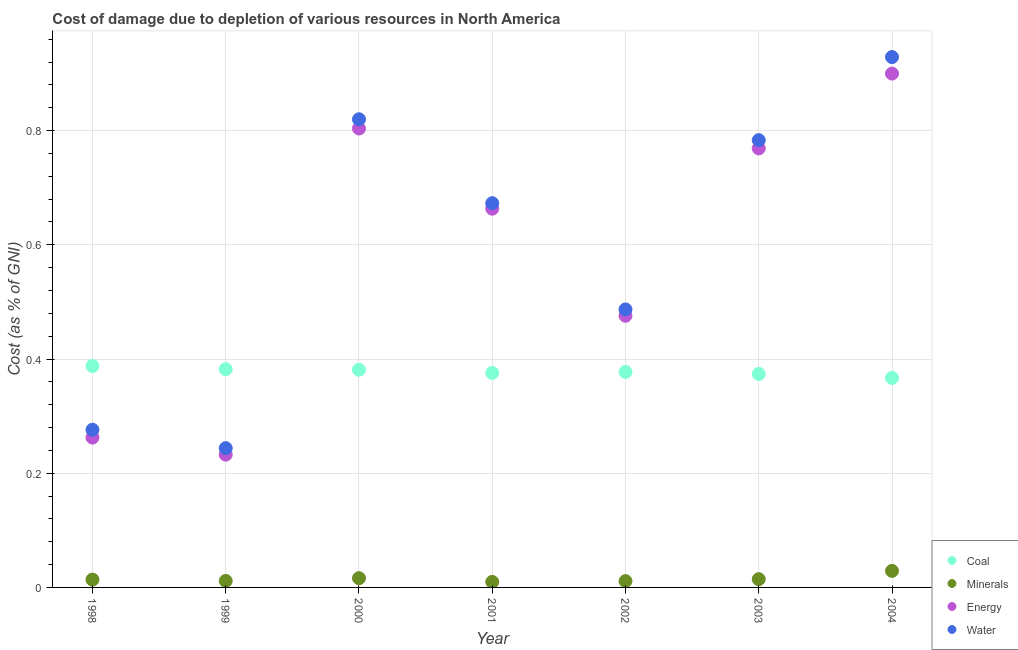How many different coloured dotlines are there?
Offer a very short reply. 4. Is the number of dotlines equal to the number of legend labels?
Your response must be concise. Yes. What is the cost of damage due to depletion of energy in 2001?
Offer a very short reply. 0.66. Across all years, what is the maximum cost of damage due to depletion of water?
Your response must be concise. 0.93. Across all years, what is the minimum cost of damage due to depletion of water?
Your answer should be compact. 0.24. In which year was the cost of damage due to depletion of water minimum?
Make the answer very short. 1999. What is the total cost of damage due to depletion of energy in the graph?
Offer a very short reply. 4.11. What is the difference between the cost of damage due to depletion of energy in 1998 and that in 1999?
Make the answer very short. 0.03. What is the difference between the cost of damage due to depletion of water in 2002 and the cost of damage due to depletion of minerals in 2000?
Make the answer very short. 0.47. What is the average cost of damage due to depletion of minerals per year?
Provide a succinct answer. 0.02. In the year 2000, what is the difference between the cost of damage due to depletion of coal and cost of damage due to depletion of energy?
Ensure brevity in your answer.  -0.42. What is the ratio of the cost of damage due to depletion of minerals in 2003 to that in 2004?
Your response must be concise. 0.5. What is the difference between the highest and the second highest cost of damage due to depletion of coal?
Offer a terse response. 0.01. What is the difference between the highest and the lowest cost of damage due to depletion of coal?
Your response must be concise. 0.02. Is the sum of the cost of damage due to depletion of energy in 2000 and 2001 greater than the maximum cost of damage due to depletion of minerals across all years?
Your answer should be compact. Yes. Is it the case that in every year, the sum of the cost of damage due to depletion of water and cost of damage due to depletion of coal is greater than the sum of cost of damage due to depletion of minerals and cost of damage due to depletion of energy?
Provide a succinct answer. No. Is it the case that in every year, the sum of the cost of damage due to depletion of coal and cost of damage due to depletion of minerals is greater than the cost of damage due to depletion of energy?
Keep it short and to the point. No. Does the cost of damage due to depletion of minerals monotonically increase over the years?
Ensure brevity in your answer.  No. Is the cost of damage due to depletion of minerals strictly greater than the cost of damage due to depletion of water over the years?
Provide a short and direct response. No. Is the cost of damage due to depletion of minerals strictly less than the cost of damage due to depletion of water over the years?
Ensure brevity in your answer.  Yes. How many dotlines are there?
Provide a succinct answer. 4. Does the graph contain grids?
Offer a terse response. Yes. What is the title of the graph?
Provide a short and direct response. Cost of damage due to depletion of various resources in North America . What is the label or title of the X-axis?
Provide a succinct answer. Year. What is the label or title of the Y-axis?
Ensure brevity in your answer.  Cost (as % of GNI). What is the Cost (as % of GNI) of Coal in 1998?
Give a very brief answer. 0.39. What is the Cost (as % of GNI) of Minerals in 1998?
Offer a terse response. 0.01. What is the Cost (as % of GNI) in Energy in 1998?
Provide a short and direct response. 0.26. What is the Cost (as % of GNI) of Water in 1998?
Your answer should be compact. 0.28. What is the Cost (as % of GNI) of Coal in 1999?
Provide a succinct answer. 0.38. What is the Cost (as % of GNI) of Minerals in 1999?
Give a very brief answer. 0.01. What is the Cost (as % of GNI) of Energy in 1999?
Keep it short and to the point. 0.23. What is the Cost (as % of GNI) of Water in 1999?
Ensure brevity in your answer.  0.24. What is the Cost (as % of GNI) of Coal in 2000?
Provide a succinct answer. 0.38. What is the Cost (as % of GNI) in Minerals in 2000?
Your answer should be very brief. 0.02. What is the Cost (as % of GNI) of Energy in 2000?
Your answer should be compact. 0.8. What is the Cost (as % of GNI) of Water in 2000?
Your answer should be very brief. 0.82. What is the Cost (as % of GNI) of Coal in 2001?
Provide a succinct answer. 0.38. What is the Cost (as % of GNI) of Minerals in 2001?
Provide a succinct answer. 0.01. What is the Cost (as % of GNI) of Energy in 2001?
Keep it short and to the point. 0.66. What is the Cost (as % of GNI) in Water in 2001?
Offer a very short reply. 0.67. What is the Cost (as % of GNI) in Coal in 2002?
Make the answer very short. 0.38. What is the Cost (as % of GNI) of Minerals in 2002?
Provide a short and direct response. 0.01. What is the Cost (as % of GNI) in Energy in 2002?
Your answer should be very brief. 0.48. What is the Cost (as % of GNI) in Water in 2002?
Your response must be concise. 0.49. What is the Cost (as % of GNI) in Coal in 2003?
Make the answer very short. 0.37. What is the Cost (as % of GNI) of Minerals in 2003?
Offer a terse response. 0.01. What is the Cost (as % of GNI) in Energy in 2003?
Offer a very short reply. 0.77. What is the Cost (as % of GNI) in Water in 2003?
Your answer should be very brief. 0.78. What is the Cost (as % of GNI) of Coal in 2004?
Give a very brief answer. 0.37. What is the Cost (as % of GNI) of Minerals in 2004?
Give a very brief answer. 0.03. What is the Cost (as % of GNI) in Energy in 2004?
Your response must be concise. 0.9. What is the Cost (as % of GNI) of Water in 2004?
Ensure brevity in your answer.  0.93. Across all years, what is the maximum Cost (as % of GNI) in Coal?
Make the answer very short. 0.39. Across all years, what is the maximum Cost (as % of GNI) in Minerals?
Offer a terse response. 0.03. Across all years, what is the maximum Cost (as % of GNI) in Energy?
Provide a succinct answer. 0.9. Across all years, what is the maximum Cost (as % of GNI) of Water?
Ensure brevity in your answer.  0.93. Across all years, what is the minimum Cost (as % of GNI) in Coal?
Your answer should be compact. 0.37. Across all years, what is the minimum Cost (as % of GNI) of Minerals?
Ensure brevity in your answer.  0.01. Across all years, what is the minimum Cost (as % of GNI) of Energy?
Your answer should be very brief. 0.23. Across all years, what is the minimum Cost (as % of GNI) of Water?
Offer a very short reply. 0.24. What is the total Cost (as % of GNI) in Coal in the graph?
Your answer should be compact. 2.65. What is the total Cost (as % of GNI) in Minerals in the graph?
Provide a succinct answer. 0.11. What is the total Cost (as % of GNI) of Energy in the graph?
Your response must be concise. 4.11. What is the total Cost (as % of GNI) of Water in the graph?
Your response must be concise. 4.21. What is the difference between the Cost (as % of GNI) in Coal in 1998 and that in 1999?
Offer a terse response. 0.01. What is the difference between the Cost (as % of GNI) of Minerals in 1998 and that in 1999?
Make the answer very short. 0. What is the difference between the Cost (as % of GNI) of Energy in 1998 and that in 1999?
Offer a very short reply. 0.03. What is the difference between the Cost (as % of GNI) in Water in 1998 and that in 1999?
Keep it short and to the point. 0.03. What is the difference between the Cost (as % of GNI) in Coal in 1998 and that in 2000?
Your answer should be very brief. 0.01. What is the difference between the Cost (as % of GNI) of Minerals in 1998 and that in 2000?
Your answer should be compact. -0. What is the difference between the Cost (as % of GNI) of Energy in 1998 and that in 2000?
Provide a short and direct response. -0.54. What is the difference between the Cost (as % of GNI) in Water in 1998 and that in 2000?
Your answer should be compact. -0.54. What is the difference between the Cost (as % of GNI) of Coal in 1998 and that in 2001?
Offer a very short reply. 0.01. What is the difference between the Cost (as % of GNI) of Minerals in 1998 and that in 2001?
Give a very brief answer. 0. What is the difference between the Cost (as % of GNI) in Energy in 1998 and that in 2001?
Your response must be concise. -0.4. What is the difference between the Cost (as % of GNI) of Water in 1998 and that in 2001?
Your answer should be very brief. -0.4. What is the difference between the Cost (as % of GNI) of Coal in 1998 and that in 2002?
Provide a short and direct response. 0.01. What is the difference between the Cost (as % of GNI) in Minerals in 1998 and that in 2002?
Provide a short and direct response. 0. What is the difference between the Cost (as % of GNI) in Energy in 1998 and that in 2002?
Offer a very short reply. -0.21. What is the difference between the Cost (as % of GNI) of Water in 1998 and that in 2002?
Your answer should be compact. -0.21. What is the difference between the Cost (as % of GNI) in Coal in 1998 and that in 2003?
Provide a succinct answer. 0.01. What is the difference between the Cost (as % of GNI) of Minerals in 1998 and that in 2003?
Offer a very short reply. -0. What is the difference between the Cost (as % of GNI) of Energy in 1998 and that in 2003?
Give a very brief answer. -0.51. What is the difference between the Cost (as % of GNI) of Water in 1998 and that in 2003?
Make the answer very short. -0.51. What is the difference between the Cost (as % of GNI) of Coal in 1998 and that in 2004?
Make the answer very short. 0.02. What is the difference between the Cost (as % of GNI) of Minerals in 1998 and that in 2004?
Keep it short and to the point. -0.02. What is the difference between the Cost (as % of GNI) of Energy in 1998 and that in 2004?
Provide a succinct answer. -0.64. What is the difference between the Cost (as % of GNI) of Water in 1998 and that in 2004?
Your response must be concise. -0.65. What is the difference between the Cost (as % of GNI) of Coal in 1999 and that in 2000?
Keep it short and to the point. 0. What is the difference between the Cost (as % of GNI) in Minerals in 1999 and that in 2000?
Your response must be concise. -0. What is the difference between the Cost (as % of GNI) in Energy in 1999 and that in 2000?
Your response must be concise. -0.57. What is the difference between the Cost (as % of GNI) in Water in 1999 and that in 2000?
Provide a succinct answer. -0.58. What is the difference between the Cost (as % of GNI) in Coal in 1999 and that in 2001?
Your response must be concise. 0.01. What is the difference between the Cost (as % of GNI) in Minerals in 1999 and that in 2001?
Ensure brevity in your answer.  0. What is the difference between the Cost (as % of GNI) of Energy in 1999 and that in 2001?
Make the answer very short. -0.43. What is the difference between the Cost (as % of GNI) in Water in 1999 and that in 2001?
Your response must be concise. -0.43. What is the difference between the Cost (as % of GNI) of Coal in 1999 and that in 2002?
Keep it short and to the point. 0. What is the difference between the Cost (as % of GNI) of Minerals in 1999 and that in 2002?
Ensure brevity in your answer.  0. What is the difference between the Cost (as % of GNI) of Energy in 1999 and that in 2002?
Offer a terse response. -0.24. What is the difference between the Cost (as % of GNI) of Water in 1999 and that in 2002?
Your answer should be very brief. -0.24. What is the difference between the Cost (as % of GNI) of Coal in 1999 and that in 2003?
Ensure brevity in your answer.  0.01. What is the difference between the Cost (as % of GNI) of Minerals in 1999 and that in 2003?
Offer a terse response. -0. What is the difference between the Cost (as % of GNI) of Energy in 1999 and that in 2003?
Provide a short and direct response. -0.54. What is the difference between the Cost (as % of GNI) of Water in 1999 and that in 2003?
Your answer should be very brief. -0.54. What is the difference between the Cost (as % of GNI) of Coal in 1999 and that in 2004?
Provide a succinct answer. 0.02. What is the difference between the Cost (as % of GNI) in Minerals in 1999 and that in 2004?
Your answer should be compact. -0.02. What is the difference between the Cost (as % of GNI) in Energy in 1999 and that in 2004?
Make the answer very short. -0.67. What is the difference between the Cost (as % of GNI) in Water in 1999 and that in 2004?
Offer a terse response. -0.68. What is the difference between the Cost (as % of GNI) of Coal in 2000 and that in 2001?
Your answer should be compact. 0.01. What is the difference between the Cost (as % of GNI) of Minerals in 2000 and that in 2001?
Make the answer very short. 0.01. What is the difference between the Cost (as % of GNI) of Energy in 2000 and that in 2001?
Keep it short and to the point. 0.14. What is the difference between the Cost (as % of GNI) of Water in 2000 and that in 2001?
Provide a succinct answer. 0.15. What is the difference between the Cost (as % of GNI) of Coal in 2000 and that in 2002?
Keep it short and to the point. 0. What is the difference between the Cost (as % of GNI) in Minerals in 2000 and that in 2002?
Offer a very short reply. 0.01. What is the difference between the Cost (as % of GNI) in Energy in 2000 and that in 2002?
Make the answer very short. 0.33. What is the difference between the Cost (as % of GNI) in Water in 2000 and that in 2002?
Make the answer very short. 0.33. What is the difference between the Cost (as % of GNI) of Coal in 2000 and that in 2003?
Provide a succinct answer. 0.01. What is the difference between the Cost (as % of GNI) of Minerals in 2000 and that in 2003?
Ensure brevity in your answer.  0. What is the difference between the Cost (as % of GNI) in Energy in 2000 and that in 2003?
Your answer should be compact. 0.03. What is the difference between the Cost (as % of GNI) in Water in 2000 and that in 2003?
Your answer should be compact. 0.04. What is the difference between the Cost (as % of GNI) in Coal in 2000 and that in 2004?
Your answer should be compact. 0.01. What is the difference between the Cost (as % of GNI) of Minerals in 2000 and that in 2004?
Ensure brevity in your answer.  -0.01. What is the difference between the Cost (as % of GNI) in Energy in 2000 and that in 2004?
Provide a short and direct response. -0.1. What is the difference between the Cost (as % of GNI) in Water in 2000 and that in 2004?
Ensure brevity in your answer.  -0.11. What is the difference between the Cost (as % of GNI) in Coal in 2001 and that in 2002?
Offer a terse response. -0. What is the difference between the Cost (as % of GNI) in Minerals in 2001 and that in 2002?
Give a very brief answer. -0. What is the difference between the Cost (as % of GNI) in Energy in 2001 and that in 2002?
Provide a succinct answer. 0.19. What is the difference between the Cost (as % of GNI) in Water in 2001 and that in 2002?
Ensure brevity in your answer.  0.19. What is the difference between the Cost (as % of GNI) in Coal in 2001 and that in 2003?
Your answer should be very brief. 0. What is the difference between the Cost (as % of GNI) in Minerals in 2001 and that in 2003?
Keep it short and to the point. -0. What is the difference between the Cost (as % of GNI) in Energy in 2001 and that in 2003?
Your answer should be very brief. -0.11. What is the difference between the Cost (as % of GNI) in Water in 2001 and that in 2003?
Keep it short and to the point. -0.11. What is the difference between the Cost (as % of GNI) in Coal in 2001 and that in 2004?
Keep it short and to the point. 0.01. What is the difference between the Cost (as % of GNI) in Minerals in 2001 and that in 2004?
Your answer should be very brief. -0.02. What is the difference between the Cost (as % of GNI) in Energy in 2001 and that in 2004?
Your answer should be compact. -0.24. What is the difference between the Cost (as % of GNI) of Water in 2001 and that in 2004?
Offer a very short reply. -0.26. What is the difference between the Cost (as % of GNI) of Coal in 2002 and that in 2003?
Your answer should be compact. 0. What is the difference between the Cost (as % of GNI) of Minerals in 2002 and that in 2003?
Make the answer very short. -0. What is the difference between the Cost (as % of GNI) in Energy in 2002 and that in 2003?
Your response must be concise. -0.29. What is the difference between the Cost (as % of GNI) in Water in 2002 and that in 2003?
Your answer should be compact. -0.3. What is the difference between the Cost (as % of GNI) in Coal in 2002 and that in 2004?
Make the answer very short. 0.01. What is the difference between the Cost (as % of GNI) in Minerals in 2002 and that in 2004?
Offer a very short reply. -0.02. What is the difference between the Cost (as % of GNI) in Energy in 2002 and that in 2004?
Your answer should be very brief. -0.42. What is the difference between the Cost (as % of GNI) of Water in 2002 and that in 2004?
Keep it short and to the point. -0.44. What is the difference between the Cost (as % of GNI) of Coal in 2003 and that in 2004?
Give a very brief answer. 0.01. What is the difference between the Cost (as % of GNI) of Minerals in 2003 and that in 2004?
Provide a succinct answer. -0.01. What is the difference between the Cost (as % of GNI) in Energy in 2003 and that in 2004?
Offer a very short reply. -0.13. What is the difference between the Cost (as % of GNI) in Water in 2003 and that in 2004?
Your answer should be very brief. -0.15. What is the difference between the Cost (as % of GNI) of Coal in 1998 and the Cost (as % of GNI) of Minerals in 1999?
Offer a terse response. 0.38. What is the difference between the Cost (as % of GNI) of Coal in 1998 and the Cost (as % of GNI) of Energy in 1999?
Your answer should be very brief. 0.16. What is the difference between the Cost (as % of GNI) of Coal in 1998 and the Cost (as % of GNI) of Water in 1999?
Provide a succinct answer. 0.14. What is the difference between the Cost (as % of GNI) of Minerals in 1998 and the Cost (as % of GNI) of Energy in 1999?
Keep it short and to the point. -0.22. What is the difference between the Cost (as % of GNI) of Minerals in 1998 and the Cost (as % of GNI) of Water in 1999?
Make the answer very short. -0.23. What is the difference between the Cost (as % of GNI) in Energy in 1998 and the Cost (as % of GNI) in Water in 1999?
Provide a succinct answer. 0.02. What is the difference between the Cost (as % of GNI) of Coal in 1998 and the Cost (as % of GNI) of Minerals in 2000?
Your answer should be very brief. 0.37. What is the difference between the Cost (as % of GNI) in Coal in 1998 and the Cost (as % of GNI) in Energy in 2000?
Give a very brief answer. -0.42. What is the difference between the Cost (as % of GNI) of Coal in 1998 and the Cost (as % of GNI) of Water in 2000?
Offer a very short reply. -0.43. What is the difference between the Cost (as % of GNI) of Minerals in 1998 and the Cost (as % of GNI) of Energy in 2000?
Your response must be concise. -0.79. What is the difference between the Cost (as % of GNI) of Minerals in 1998 and the Cost (as % of GNI) of Water in 2000?
Keep it short and to the point. -0.81. What is the difference between the Cost (as % of GNI) in Energy in 1998 and the Cost (as % of GNI) in Water in 2000?
Give a very brief answer. -0.56. What is the difference between the Cost (as % of GNI) in Coal in 1998 and the Cost (as % of GNI) in Minerals in 2001?
Make the answer very short. 0.38. What is the difference between the Cost (as % of GNI) of Coal in 1998 and the Cost (as % of GNI) of Energy in 2001?
Your answer should be very brief. -0.28. What is the difference between the Cost (as % of GNI) in Coal in 1998 and the Cost (as % of GNI) in Water in 2001?
Your answer should be very brief. -0.29. What is the difference between the Cost (as % of GNI) in Minerals in 1998 and the Cost (as % of GNI) in Energy in 2001?
Provide a succinct answer. -0.65. What is the difference between the Cost (as % of GNI) in Minerals in 1998 and the Cost (as % of GNI) in Water in 2001?
Your response must be concise. -0.66. What is the difference between the Cost (as % of GNI) in Energy in 1998 and the Cost (as % of GNI) in Water in 2001?
Keep it short and to the point. -0.41. What is the difference between the Cost (as % of GNI) of Coal in 1998 and the Cost (as % of GNI) of Minerals in 2002?
Provide a succinct answer. 0.38. What is the difference between the Cost (as % of GNI) of Coal in 1998 and the Cost (as % of GNI) of Energy in 2002?
Make the answer very short. -0.09. What is the difference between the Cost (as % of GNI) of Coal in 1998 and the Cost (as % of GNI) of Water in 2002?
Your answer should be compact. -0.1. What is the difference between the Cost (as % of GNI) of Minerals in 1998 and the Cost (as % of GNI) of Energy in 2002?
Offer a very short reply. -0.46. What is the difference between the Cost (as % of GNI) in Minerals in 1998 and the Cost (as % of GNI) in Water in 2002?
Provide a succinct answer. -0.47. What is the difference between the Cost (as % of GNI) in Energy in 1998 and the Cost (as % of GNI) in Water in 2002?
Offer a terse response. -0.22. What is the difference between the Cost (as % of GNI) of Coal in 1998 and the Cost (as % of GNI) of Minerals in 2003?
Your answer should be very brief. 0.37. What is the difference between the Cost (as % of GNI) of Coal in 1998 and the Cost (as % of GNI) of Energy in 2003?
Make the answer very short. -0.38. What is the difference between the Cost (as % of GNI) of Coal in 1998 and the Cost (as % of GNI) of Water in 2003?
Provide a short and direct response. -0.4. What is the difference between the Cost (as % of GNI) in Minerals in 1998 and the Cost (as % of GNI) in Energy in 2003?
Provide a short and direct response. -0.76. What is the difference between the Cost (as % of GNI) of Minerals in 1998 and the Cost (as % of GNI) of Water in 2003?
Your answer should be compact. -0.77. What is the difference between the Cost (as % of GNI) of Energy in 1998 and the Cost (as % of GNI) of Water in 2003?
Make the answer very short. -0.52. What is the difference between the Cost (as % of GNI) in Coal in 1998 and the Cost (as % of GNI) in Minerals in 2004?
Offer a terse response. 0.36. What is the difference between the Cost (as % of GNI) in Coal in 1998 and the Cost (as % of GNI) in Energy in 2004?
Your answer should be compact. -0.51. What is the difference between the Cost (as % of GNI) in Coal in 1998 and the Cost (as % of GNI) in Water in 2004?
Your answer should be very brief. -0.54. What is the difference between the Cost (as % of GNI) of Minerals in 1998 and the Cost (as % of GNI) of Energy in 2004?
Your answer should be compact. -0.89. What is the difference between the Cost (as % of GNI) in Minerals in 1998 and the Cost (as % of GNI) in Water in 2004?
Provide a short and direct response. -0.92. What is the difference between the Cost (as % of GNI) in Energy in 1998 and the Cost (as % of GNI) in Water in 2004?
Your answer should be compact. -0.67. What is the difference between the Cost (as % of GNI) of Coal in 1999 and the Cost (as % of GNI) of Minerals in 2000?
Provide a short and direct response. 0.37. What is the difference between the Cost (as % of GNI) of Coal in 1999 and the Cost (as % of GNI) of Energy in 2000?
Offer a very short reply. -0.42. What is the difference between the Cost (as % of GNI) of Coal in 1999 and the Cost (as % of GNI) of Water in 2000?
Make the answer very short. -0.44. What is the difference between the Cost (as % of GNI) of Minerals in 1999 and the Cost (as % of GNI) of Energy in 2000?
Your answer should be very brief. -0.79. What is the difference between the Cost (as % of GNI) of Minerals in 1999 and the Cost (as % of GNI) of Water in 2000?
Ensure brevity in your answer.  -0.81. What is the difference between the Cost (as % of GNI) of Energy in 1999 and the Cost (as % of GNI) of Water in 2000?
Keep it short and to the point. -0.59. What is the difference between the Cost (as % of GNI) of Coal in 1999 and the Cost (as % of GNI) of Minerals in 2001?
Your answer should be very brief. 0.37. What is the difference between the Cost (as % of GNI) of Coal in 1999 and the Cost (as % of GNI) of Energy in 2001?
Provide a short and direct response. -0.28. What is the difference between the Cost (as % of GNI) in Coal in 1999 and the Cost (as % of GNI) in Water in 2001?
Give a very brief answer. -0.29. What is the difference between the Cost (as % of GNI) in Minerals in 1999 and the Cost (as % of GNI) in Energy in 2001?
Make the answer very short. -0.65. What is the difference between the Cost (as % of GNI) of Minerals in 1999 and the Cost (as % of GNI) of Water in 2001?
Your response must be concise. -0.66. What is the difference between the Cost (as % of GNI) of Energy in 1999 and the Cost (as % of GNI) of Water in 2001?
Offer a terse response. -0.44. What is the difference between the Cost (as % of GNI) of Coal in 1999 and the Cost (as % of GNI) of Minerals in 2002?
Provide a succinct answer. 0.37. What is the difference between the Cost (as % of GNI) in Coal in 1999 and the Cost (as % of GNI) in Energy in 2002?
Give a very brief answer. -0.09. What is the difference between the Cost (as % of GNI) of Coal in 1999 and the Cost (as % of GNI) of Water in 2002?
Keep it short and to the point. -0.1. What is the difference between the Cost (as % of GNI) of Minerals in 1999 and the Cost (as % of GNI) of Energy in 2002?
Your answer should be compact. -0.46. What is the difference between the Cost (as % of GNI) of Minerals in 1999 and the Cost (as % of GNI) of Water in 2002?
Offer a terse response. -0.48. What is the difference between the Cost (as % of GNI) of Energy in 1999 and the Cost (as % of GNI) of Water in 2002?
Give a very brief answer. -0.25. What is the difference between the Cost (as % of GNI) in Coal in 1999 and the Cost (as % of GNI) in Minerals in 2003?
Your answer should be very brief. 0.37. What is the difference between the Cost (as % of GNI) in Coal in 1999 and the Cost (as % of GNI) in Energy in 2003?
Keep it short and to the point. -0.39. What is the difference between the Cost (as % of GNI) in Coal in 1999 and the Cost (as % of GNI) in Water in 2003?
Make the answer very short. -0.4. What is the difference between the Cost (as % of GNI) of Minerals in 1999 and the Cost (as % of GNI) of Energy in 2003?
Ensure brevity in your answer.  -0.76. What is the difference between the Cost (as % of GNI) of Minerals in 1999 and the Cost (as % of GNI) of Water in 2003?
Give a very brief answer. -0.77. What is the difference between the Cost (as % of GNI) in Energy in 1999 and the Cost (as % of GNI) in Water in 2003?
Your answer should be very brief. -0.55. What is the difference between the Cost (as % of GNI) in Coal in 1999 and the Cost (as % of GNI) in Minerals in 2004?
Offer a terse response. 0.35. What is the difference between the Cost (as % of GNI) of Coal in 1999 and the Cost (as % of GNI) of Energy in 2004?
Give a very brief answer. -0.52. What is the difference between the Cost (as % of GNI) in Coal in 1999 and the Cost (as % of GNI) in Water in 2004?
Ensure brevity in your answer.  -0.55. What is the difference between the Cost (as % of GNI) in Minerals in 1999 and the Cost (as % of GNI) in Energy in 2004?
Make the answer very short. -0.89. What is the difference between the Cost (as % of GNI) of Minerals in 1999 and the Cost (as % of GNI) of Water in 2004?
Provide a succinct answer. -0.92. What is the difference between the Cost (as % of GNI) in Energy in 1999 and the Cost (as % of GNI) in Water in 2004?
Your response must be concise. -0.7. What is the difference between the Cost (as % of GNI) in Coal in 2000 and the Cost (as % of GNI) in Minerals in 2001?
Offer a very short reply. 0.37. What is the difference between the Cost (as % of GNI) of Coal in 2000 and the Cost (as % of GNI) of Energy in 2001?
Ensure brevity in your answer.  -0.28. What is the difference between the Cost (as % of GNI) of Coal in 2000 and the Cost (as % of GNI) of Water in 2001?
Give a very brief answer. -0.29. What is the difference between the Cost (as % of GNI) in Minerals in 2000 and the Cost (as % of GNI) in Energy in 2001?
Provide a succinct answer. -0.65. What is the difference between the Cost (as % of GNI) of Minerals in 2000 and the Cost (as % of GNI) of Water in 2001?
Offer a very short reply. -0.66. What is the difference between the Cost (as % of GNI) of Energy in 2000 and the Cost (as % of GNI) of Water in 2001?
Offer a very short reply. 0.13. What is the difference between the Cost (as % of GNI) of Coal in 2000 and the Cost (as % of GNI) of Minerals in 2002?
Provide a succinct answer. 0.37. What is the difference between the Cost (as % of GNI) in Coal in 2000 and the Cost (as % of GNI) in Energy in 2002?
Give a very brief answer. -0.09. What is the difference between the Cost (as % of GNI) in Coal in 2000 and the Cost (as % of GNI) in Water in 2002?
Your response must be concise. -0.11. What is the difference between the Cost (as % of GNI) of Minerals in 2000 and the Cost (as % of GNI) of Energy in 2002?
Your response must be concise. -0.46. What is the difference between the Cost (as % of GNI) of Minerals in 2000 and the Cost (as % of GNI) of Water in 2002?
Your answer should be compact. -0.47. What is the difference between the Cost (as % of GNI) of Energy in 2000 and the Cost (as % of GNI) of Water in 2002?
Your answer should be compact. 0.32. What is the difference between the Cost (as % of GNI) in Coal in 2000 and the Cost (as % of GNI) in Minerals in 2003?
Your answer should be compact. 0.37. What is the difference between the Cost (as % of GNI) in Coal in 2000 and the Cost (as % of GNI) in Energy in 2003?
Offer a terse response. -0.39. What is the difference between the Cost (as % of GNI) of Coal in 2000 and the Cost (as % of GNI) of Water in 2003?
Keep it short and to the point. -0.4. What is the difference between the Cost (as % of GNI) in Minerals in 2000 and the Cost (as % of GNI) in Energy in 2003?
Offer a very short reply. -0.75. What is the difference between the Cost (as % of GNI) in Minerals in 2000 and the Cost (as % of GNI) in Water in 2003?
Provide a short and direct response. -0.77. What is the difference between the Cost (as % of GNI) in Energy in 2000 and the Cost (as % of GNI) in Water in 2003?
Keep it short and to the point. 0.02. What is the difference between the Cost (as % of GNI) in Coal in 2000 and the Cost (as % of GNI) in Minerals in 2004?
Make the answer very short. 0.35. What is the difference between the Cost (as % of GNI) in Coal in 2000 and the Cost (as % of GNI) in Energy in 2004?
Your response must be concise. -0.52. What is the difference between the Cost (as % of GNI) in Coal in 2000 and the Cost (as % of GNI) in Water in 2004?
Offer a terse response. -0.55. What is the difference between the Cost (as % of GNI) of Minerals in 2000 and the Cost (as % of GNI) of Energy in 2004?
Ensure brevity in your answer.  -0.88. What is the difference between the Cost (as % of GNI) in Minerals in 2000 and the Cost (as % of GNI) in Water in 2004?
Your response must be concise. -0.91. What is the difference between the Cost (as % of GNI) in Energy in 2000 and the Cost (as % of GNI) in Water in 2004?
Your answer should be very brief. -0.13. What is the difference between the Cost (as % of GNI) in Coal in 2001 and the Cost (as % of GNI) in Minerals in 2002?
Ensure brevity in your answer.  0.36. What is the difference between the Cost (as % of GNI) in Coal in 2001 and the Cost (as % of GNI) in Energy in 2002?
Ensure brevity in your answer.  -0.1. What is the difference between the Cost (as % of GNI) of Coal in 2001 and the Cost (as % of GNI) of Water in 2002?
Provide a short and direct response. -0.11. What is the difference between the Cost (as % of GNI) in Minerals in 2001 and the Cost (as % of GNI) in Energy in 2002?
Your response must be concise. -0.47. What is the difference between the Cost (as % of GNI) in Minerals in 2001 and the Cost (as % of GNI) in Water in 2002?
Make the answer very short. -0.48. What is the difference between the Cost (as % of GNI) in Energy in 2001 and the Cost (as % of GNI) in Water in 2002?
Your answer should be compact. 0.18. What is the difference between the Cost (as % of GNI) in Coal in 2001 and the Cost (as % of GNI) in Minerals in 2003?
Offer a terse response. 0.36. What is the difference between the Cost (as % of GNI) of Coal in 2001 and the Cost (as % of GNI) of Energy in 2003?
Your answer should be very brief. -0.39. What is the difference between the Cost (as % of GNI) in Coal in 2001 and the Cost (as % of GNI) in Water in 2003?
Ensure brevity in your answer.  -0.41. What is the difference between the Cost (as % of GNI) in Minerals in 2001 and the Cost (as % of GNI) in Energy in 2003?
Make the answer very short. -0.76. What is the difference between the Cost (as % of GNI) of Minerals in 2001 and the Cost (as % of GNI) of Water in 2003?
Provide a succinct answer. -0.77. What is the difference between the Cost (as % of GNI) of Energy in 2001 and the Cost (as % of GNI) of Water in 2003?
Ensure brevity in your answer.  -0.12. What is the difference between the Cost (as % of GNI) of Coal in 2001 and the Cost (as % of GNI) of Minerals in 2004?
Give a very brief answer. 0.35. What is the difference between the Cost (as % of GNI) in Coal in 2001 and the Cost (as % of GNI) in Energy in 2004?
Provide a short and direct response. -0.52. What is the difference between the Cost (as % of GNI) of Coal in 2001 and the Cost (as % of GNI) of Water in 2004?
Give a very brief answer. -0.55. What is the difference between the Cost (as % of GNI) of Minerals in 2001 and the Cost (as % of GNI) of Energy in 2004?
Provide a succinct answer. -0.89. What is the difference between the Cost (as % of GNI) in Minerals in 2001 and the Cost (as % of GNI) in Water in 2004?
Provide a succinct answer. -0.92. What is the difference between the Cost (as % of GNI) of Energy in 2001 and the Cost (as % of GNI) of Water in 2004?
Your answer should be compact. -0.27. What is the difference between the Cost (as % of GNI) in Coal in 2002 and the Cost (as % of GNI) in Minerals in 2003?
Your response must be concise. 0.36. What is the difference between the Cost (as % of GNI) of Coal in 2002 and the Cost (as % of GNI) of Energy in 2003?
Your answer should be compact. -0.39. What is the difference between the Cost (as % of GNI) of Coal in 2002 and the Cost (as % of GNI) of Water in 2003?
Your response must be concise. -0.41. What is the difference between the Cost (as % of GNI) of Minerals in 2002 and the Cost (as % of GNI) of Energy in 2003?
Offer a very short reply. -0.76. What is the difference between the Cost (as % of GNI) in Minerals in 2002 and the Cost (as % of GNI) in Water in 2003?
Your answer should be very brief. -0.77. What is the difference between the Cost (as % of GNI) in Energy in 2002 and the Cost (as % of GNI) in Water in 2003?
Offer a very short reply. -0.31. What is the difference between the Cost (as % of GNI) in Coal in 2002 and the Cost (as % of GNI) in Minerals in 2004?
Provide a succinct answer. 0.35. What is the difference between the Cost (as % of GNI) in Coal in 2002 and the Cost (as % of GNI) in Energy in 2004?
Your response must be concise. -0.52. What is the difference between the Cost (as % of GNI) of Coal in 2002 and the Cost (as % of GNI) of Water in 2004?
Your response must be concise. -0.55. What is the difference between the Cost (as % of GNI) in Minerals in 2002 and the Cost (as % of GNI) in Energy in 2004?
Your response must be concise. -0.89. What is the difference between the Cost (as % of GNI) of Minerals in 2002 and the Cost (as % of GNI) of Water in 2004?
Make the answer very short. -0.92. What is the difference between the Cost (as % of GNI) of Energy in 2002 and the Cost (as % of GNI) of Water in 2004?
Keep it short and to the point. -0.45. What is the difference between the Cost (as % of GNI) of Coal in 2003 and the Cost (as % of GNI) of Minerals in 2004?
Give a very brief answer. 0.34. What is the difference between the Cost (as % of GNI) in Coal in 2003 and the Cost (as % of GNI) in Energy in 2004?
Your response must be concise. -0.53. What is the difference between the Cost (as % of GNI) of Coal in 2003 and the Cost (as % of GNI) of Water in 2004?
Your answer should be very brief. -0.55. What is the difference between the Cost (as % of GNI) of Minerals in 2003 and the Cost (as % of GNI) of Energy in 2004?
Your response must be concise. -0.89. What is the difference between the Cost (as % of GNI) of Minerals in 2003 and the Cost (as % of GNI) of Water in 2004?
Offer a very short reply. -0.91. What is the difference between the Cost (as % of GNI) in Energy in 2003 and the Cost (as % of GNI) in Water in 2004?
Ensure brevity in your answer.  -0.16. What is the average Cost (as % of GNI) of Coal per year?
Offer a very short reply. 0.38. What is the average Cost (as % of GNI) of Minerals per year?
Your response must be concise. 0.02. What is the average Cost (as % of GNI) in Energy per year?
Offer a very short reply. 0.59. What is the average Cost (as % of GNI) in Water per year?
Your response must be concise. 0.6. In the year 1998, what is the difference between the Cost (as % of GNI) of Coal and Cost (as % of GNI) of Minerals?
Offer a very short reply. 0.37. In the year 1998, what is the difference between the Cost (as % of GNI) of Coal and Cost (as % of GNI) of Energy?
Provide a short and direct response. 0.13. In the year 1998, what is the difference between the Cost (as % of GNI) in Coal and Cost (as % of GNI) in Water?
Provide a succinct answer. 0.11. In the year 1998, what is the difference between the Cost (as % of GNI) of Minerals and Cost (as % of GNI) of Energy?
Keep it short and to the point. -0.25. In the year 1998, what is the difference between the Cost (as % of GNI) of Minerals and Cost (as % of GNI) of Water?
Ensure brevity in your answer.  -0.26. In the year 1998, what is the difference between the Cost (as % of GNI) of Energy and Cost (as % of GNI) of Water?
Offer a very short reply. -0.01. In the year 1999, what is the difference between the Cost (as % of GNI) of Coal and Cost (as % of GNI) of Minerals?
Ensure brevity in your answer.  0.37. In the year 1999, what is the difference between the Cost (as % of GNI) in Coal and Cost (as % of GNI) in Energy?
Keep it short and to the point. 0.15. In the year 1999, what is the difference between the Cost (as % of GNI) of Coal and Cost (as % of GNI) of Water?
Ensure brevity in your answer.  0.14. In the year 1999, what is the difference between the Cost (as % of GNI) of Minerals and Cost (as % of GNI) of Energy?
Give a very brief answer. -0.22. In the year 1999, what is the difference between the Cost (as % of GNI) of Minerals and Cost (as % of GNI) of Water?
Provide a succinct answer. -0.23. In the year 1999, what is the difference between the Cost (as % of GNI) in Energy and Cost (as % of GNI) in Water?
Your answer should be very brief. -0.01. In the year 2000, what is the difference between the Cost (as % of GNI) of Coal and Cost (as % of GNI) of Minerals?
Offer a terse response. 0.36. In the year 2000, what is the difference between the Cost (as % of GNI) in Coal and Cost (as % of GNI) in Energy?
Offer a very short reply. -0.42. In the year 2000, what is the difference between the Cost (as % of GNI) in Coal and Cost (as % of GNI) in Water?
Keep it short and to the point. -0.44. In the year 2000, what is the difference between the Cost (as % of GNI) of Minerals and Cost (as % of GNI) of Energy?
Ensure brevity in your answer.  -0.79. In the year 2000, what is the difference between the Cost (as % of GNI) in Minerals and Cost (as % of GNI) in Water?
Your answer should be very brief. -0.8. In the year 2000, what is the difference between the Cost (as % of GNI) in Energy and Cost (as % of GNI) in Water?
Give a very brief answer. -0.02. In the year 2001, what is the difference between the Cost (as % of GNI) in Coal and Cost (as % of GNI) in Minerals?
Provide a succinct answer. 0.37. In the year 2001, what is the difference between the Cost (as % of GNI) of Coal and Cost (as % of GNI) of Energy?
Provide a succinct answer. -0.29. In the year 2001, what is the difference between the Cost (as % of GNI) in Coal and Cost (as % of GNI) in Water?
Provide a succinct answer. -0.3. In the year 2001, what is the difference between the Cost (as % of GNI) in Minerals and Cost (as % of GNI) in Energy?
Provide a succinct answer. -0.65. In the year 2001, what is the difference between the Cost (as % of GNI) in Minerals and Cost (as % of GNI) in Water?
Provide a succinct answer. -0.66. In the year 2001, what is the difference between the Cost (as % of GNI) in Energy and Cost (as % of GNI) in Water?
Your answer should be very brief. -0.01. In the year 2002, what is the difference between the Cost (as % of GNI) in Coal and Cost (as % of GNI) in Minerals?
Your answer should be very brief. 0.37. In the year 2002, what is the difference between the Cost (as % of GNI) in Coal and Cost (as % of GNI) in Energy?
Offer a very short reply. -0.1. In the year 2002, what is the difference between the Cost (as % of GNI) in Coal and Cost (as % of GNI) in Water?
Your response must be concise. -0.11. In the year 2002, what is the difference between the Cost (as % of GNI) of Minerals and Cost (as % of GNI) of Energy?
Provide a short and direct response. -0.46. In the year 2002, what is the difference between the Cost (as % of GNI) of Minerals and Cost (as % of GNI) of Water?
Ensure brevity in your answer.  -0.48. In the year 2002, what is the difference between the Cost (as % of GNI) in Energy and Cost (as % of GNI) in Water?
Your answer should be very brief. -0.01. In the year 2003, what is the difference between the Cost (as % of GNI) in Coal and Cost (as % of GNI) in Minerals?
Your response must be concise. 0.36. In the year 2003, what is the difference between the Cost (as % of GNI) of Coal and Cost (as % of GNI) of Energy?
Provide a short and direct response. -0.4. In the year 2003, what is the difference between the Cost (as % of GNI) of Coal and Cost (as % of GNI) of Water?
Ensure brevity in your answer.  -0.41. In the year 2003, what is the difference between the Cost (as % of GNI) in Minerals and Cost (as % of GNI) in Energy?
Make the answer very short. -0.75. In the year 2003, what is the difference between the Cost (as % of GNI) in Minerals and Cost (as % of GNI) in Water?
Ensure brevity in your answer.  -0.77. In the year 2003, what is the difference between the Cost (as % of GNI) in Energy and Cost (as % of GNI) in Water?
Offer a very short reply. -0.01. In the year 2004, what is the difference between the Cost (as % of GNI) in Coal and Cost (as % of GNI) in Minerals?
Make the answer very short. 0.34. In the year 2004, what is the difference between the Cost (as % of GNI) of Coal and Cost (as % of GNI) of Energy?
Provide a short and direct response. -0.53. In the year 2004, what is the difference between the Cost (as % of GNI) of Coal and Cost (as % of GNI) of Water?
Give a very brief answer. -0.56. In the year 2004, what is the difference between the Cost (as % of GNI) in Minerals and Cost (as % of GNI) in Energy?
Your response must be concise. -0.87. In the year 2004, what is the difference between the Cost (as % of GNI) in Minerals and Cost (as % of GNI) in Water?
Your response must be concise. -0.9. In the year 2004, what is the difference between the Cost (as % of GNI) in Energy and Cost (as % of GNI) in Water?
Offer a terse response. -0.03. What is the ratio of the Cost (as % of GNI) in Coal in 1998 to that in 1999?
Keep it short and to the point. 1.01. What is the ratio of the Cost (as % of GNI) of Minerals in 1998 to that in 1999?
Provide a short and direct response. 1.2. What is the ratio of the Cost (as % of GNI) of Energy in 1998 to that in 1999?
Your answer should be very brief. 1.13. What is the ratio of the Cost (as % of GNI) in Water in 1998 to that in 1999?
Give a very brief answer. 1.13. What is the ratio of the Cost (as % of GNI) in Coal in 1998 to that in 2000?
Offer a very short reply. 1.02. What is the ratio of the Cost (as % of GNI) of Minerals in 1998 to that in 2000?
Offer a very short reply. 0.84. What is the ratio of the Cost (as % of GNI) of Energy in 1998 to that in 2000?
Ensure brevity in your answer.  0.33. What is the ratio of the Cost (as % of GNI) of Water in 1998 to that in 2000?
Your answer should be compact. 0.34. What is the ratio of the Cost (as % of GNI) of Coal in 1998 to that in 2001?
Offer a terse response. 1.03. What is the ratio of the Cost (as % of GNI) of Minerals in 1998 to that in 2001?
Your answer should be very brief. 1.42. What is the ratio of the Cost (as % of GNI) of Energy in 1998 to that in 2001?
Offer a terse response. 0.4. What is the ratio of the Cost (as % of GNI) in Water in 1998 to that in 2001?
Your response must be concise. 0.41. What is the ratio of the Cost (as % of GNI) in Coal in 1998 to that in 2002?
Provide a succinct answer. 1.03. What is the ratio of the Cost (as % of GNI) of Minerals in 1998 to that in 2002?
Make the answer very short. 1.23. What is the ratio of the Cost (as % of GNI) of Energy in 1998 to that in 2002?
Make the answer very short. 0.55. What is the ratio of the Cost (as % of GNI) of Water in 1998 to that in 2002?
Your response must be concise. 0.57. What is the ratio of the Cost (as % of GNI) of Coal in 1998 to that in 2003?
Your response must be concise. 1.04. What is the ratio of the Cost (as % of GNI) of Minerals in 1998 to that in 2003?
Provide a succinct answer. 0.95. What is the ratio of the Cost (as % of GNI) of Energy in 1998 to that in 2003?
Provide a short and direct response. 0.34. What is the ratio of the Cost (as % of GNI) in Water in 1998 to that in 2003?
Offer a very short reply. 0.35. What is the ratio of the Cost (as % of GNI) of Coal in 1998 to that in 2004?
Your answer should be compact. 1.06. What is the ratio of the Cost (as % of GNI) of Minerals in 1998 to that in 2004?
Keep it short and to the point. 0.47. What is the ratio of the Cost (as % of GNI) of Energy in 1998 to that in 2004?
Give a very brief answer. 0.29. What is the ratio of the Cost (as % of GNI) of Water in 1998 to that in 2004?
Your response must be concise. 0.3. What is the ratio of the Cost (as % of GNI) of Coal in 1999 to that in 2000?
Your answer should be compact. 1. What is the ratio of the Cost (as % of GNI) of Minerals in 1999 to that in 2000?
Give a very brief answer. 0.7. What is the ratio of the Cost (as % of GNI) of Energy in 1999 to that in 2000?
Provide a short and direct response. 0.29. What is the ratio of the Cost (as % of GNI) in Water in 1999 to that in 2000?
Offer a terse response. 0.3. What is the ratio of the Cost (as % of GNI) of Coal in 1999 to that in 2001?
Offer a terse response. 1.02. What is the ratio of the Cost (as % of GNI) of Minerals in 1999 to that in 2001?
Provide a short and direct response. 1.18. What is the ratio of the Cost (as % of GNI) of Energy in 1999 to that in 2001?
Your answer should be very brief. 0.35. What is the ratio of the Cost (as % of GNI) in Water in 1999 to that in 2001?
Your response must be concise. 0.36. What is the ratio of the Cost (as % of GNI) in Coal in 1999 to that in 2002?
Keep it short and to the point. 1.01. What is the ratio of the Cost (as % of GNI) of Minerals in 1999 to that in 2002?
Your response must be concise. 1.03. What is the ratio of the Cost (as % of GNI) in Energy in 1999 to that in 2002?
Your response must be concise. 0.49. What is the ratio of the Cost (as % of GNI) in Water in 1999 to that in 2002?
Give a very brief answer. 0.5. What is the ratio of the Cost (as % of GNI) of Coal in 1999 to that in 2003?
Offer a very short reply. 1.02. What is the ratio of the Cost (as % of GNI) of Minerals in 1999 to that in 2003?
Your answer should be compact. 0.79. What is the ratio of the Cost (as % of GNI) of Energy in 1999 to that in 2003?
Provide a succinct answer. 0.3. What is the ratio of the Cost (as % of GNI) of Water in 1999 to that in 2003?
Make the answer very short. 0.31. What is the ratio of the Cost (as % of GNI) of Coal in 1999 to that in 2004?
Make the answer very short. 1.04. What is the ratio of the Cost (as % of GNI) in Minerals in 1999 to that in 2004?
Provide a succinct answer. 0.39. What is the ratio of the Cost (as % of GNI) in Energy in 1999 to that in 2004?
Ensure brevity in your answer.  0.26. What is the ratio of the Cost (as % of GNI) of Water in 1999 to that in 2004?
Offer a very short reply. 0.26. What is the ratio of the Cost (as % of GNI) in Coal in 2000 to that in 2001?
Keep it short and to the point. 1.01. What is the ratio of the Cost (as % of GNI) of Minerals in 2000 to that in 2001?
Provide a short and direct response. 1.68. What is the ratio of the Cost (as % of GNI) of Energy in 2000 to that in 2001?
Give a very brief answer. 1.21. What is the ratio of the Cost (as % of GNI) of Water in 2000 to that in 2001?
Make the answer very short. 1.22. What is the ratio of the Cost (as % of GNI) of Minerals in 2000 to that in 2002?
Make the answer very short. 1.46. What is the ratio of the Cost (as % of GNI) in Energy in 2000 to that in 2002?
Your answer should be very brief. 1.69. What is the ratio of the Cost (as % of GNI) of Water in 2000 to that in 2002?
Ensure brevity in your answer.  1.68. What is the ratio of the Cost (as % of GNI) of Coal in 2000 to that in 2003?
Provide a short and direct response. 1.02. What is the ratio of the Cost (as % of GNI) in Minerals in 2000 to that in 2003?
Keep it short and to the point. 1.12. What is the ratio of the Cost (as % of GNI) in Energy in 2000 to that in 2003?
Provide a succinct answer. 1.05. What is the ratio of the Cost (as % of GNI) of Water in 2000 to that in 2003?
Your answer should be very brief. 1.05. What is the ratio of the Cost (as % of GNI) in Coal in 2000 to that in 2004?
Provide a succinct answer. 1.04. What is the ratio of the Cost (as % of GNI) in Minerals in 2000 to that in 2004?
Your answer should be very brief. 0.56. What is the ratio of the Cost (as % of GNI) in Energy in 2000 to that in 2004?
Ensure brevity in your answer.  0.89. What is the ratio of the Cost (as % of GNI) of Water in 2000 to that in 2004?
Keep it short and to the point. 0.88. What is the ratio of the Cost (as % of GNI) of Minerals in 2001 to that in 2002?
Keep it short and to the point. 0.87. What is the ratio of the Cost (as % of GNI) in Energy in 2001 to that in 2002?
Your response must be concise. 1.39. What is the ratio of the Cost (as % of GNI) of Water in 2001 to that in 2002?
Your answer should be compact. 1.38. What is the ratio of the Cost (as % of GNI) in Coal in 2001 to that in 2003?
Provide a succinct answer. 1. What is the ratio of the Cost (as % of GNI) in Minerals in 2001 to that in 2003?
Your answer should be very brief. 0.67. What is the ratio of the Cost (as % of GNI) of Energy in 2001 to that in 2003?
Your answer should be compact. 0.86. What is the ratio of the Cost (as % of GNI) of Water in 2001 to that in 2003?
Offer a very short reply. 0.86. What is the ratio of the Cost (as % of GNI) of Coal in 2001 to that in 2004?
Your answer should be compact. 1.02. What is the ratio of the Cost (as % of GNI) of Minerals in 2001 to that in 2004?
Give a very brief answer. 0.33. What is the ratio of the Cost (as % of GNI) in Energy in 2001 to that in 2004?
Offer a terse response. 0.74. What is the ratio of the Cost (as % of GNI) of Water in 2001 to that in 2004?
Your answer should be very brief. 0.72. What is the ratio of the Cost (as % of GNI) in Coal in 2002 to that in 2003?
Provide a short and direct response. 1.01. What is the ratio of the Cost (as % of GNI) of Minerals in 2002 to that in 2003?
Provide a short and direct response. 0.77. What is the ratio of the Cost (as % of GNI) of Energy in 2002 to that in 2003?
Offer a terse response. 0.62. What is the ratio of the Cost (as % of GNI) in Water in 2002 to that in 2003?
Offer a very short reply. 0.62. What is the ratio of the Cost (as % of GNI) in Coal in 2002 to that in 2004?
Your answer should be compact. 1.03. What is the ratio of the Cost (as % of GNI) of Minerals in 2002 to that in 2004?
Your answer should be very brief. 0.38. What is the ratio of the Cost (as % of GNI) of Energy in 2002 to that in 2004?
Give a very brief answer. 0.53. What is the ratio of the Cost (as % of GNI) of Water in 2002 to that in 2004?
Your answer should be very brief. 0.52. What is the ratio of the Cost (as % of GNI) in Coal in 2003 to that in 2004?
Your response must be concise. 1.02. What is the ratio of the Cost (as % of GNI) in Minerals in 2003 to that in 2004?
Your answer should be very brief. 0.5. What is the ratio of the Cost (as % of GNI) in Energy in 2003 to that in 2004?
Offer a very short reply. 0.85. What is the ratio of the Cost (as % of GNI) in Water in 2003 to that in 2004?
Your answer should be very brief. 0.84. What is the difference between the highest and the second highest Cost (as % of GNI) of Coal?
Your answer should be compact. 0.01. What is the difference between the highest and the second highest Cost (as % of GNI) of Minerals?
Your answer should be very brief. 0.01. What is the difference between the highest and the second highest Cost (as % of GNI) of Energy?
Provide a short and direct response. 0.1. What is the difference between the highest and the second highest Cost (as % of GNI) in Water?
Give a very brief answer. 0.11. What is the difference between the highest and the lowest Cost (as % of GNI) in Coal?
Keep it short and to the point. 0.02. What is the difference between the highest and the lowest Cost (as % of GNI) in Minerals?
Your answer should be very brief. 0.02. What is the difference between the highest and the lowest Cost (as % of GNI) in Energy?
Keep it short and to the point. 0.67. What is the difference between the highest and the lowest Cost (as % of GNI) of Water?
Give a very brief answer. 0.68. 